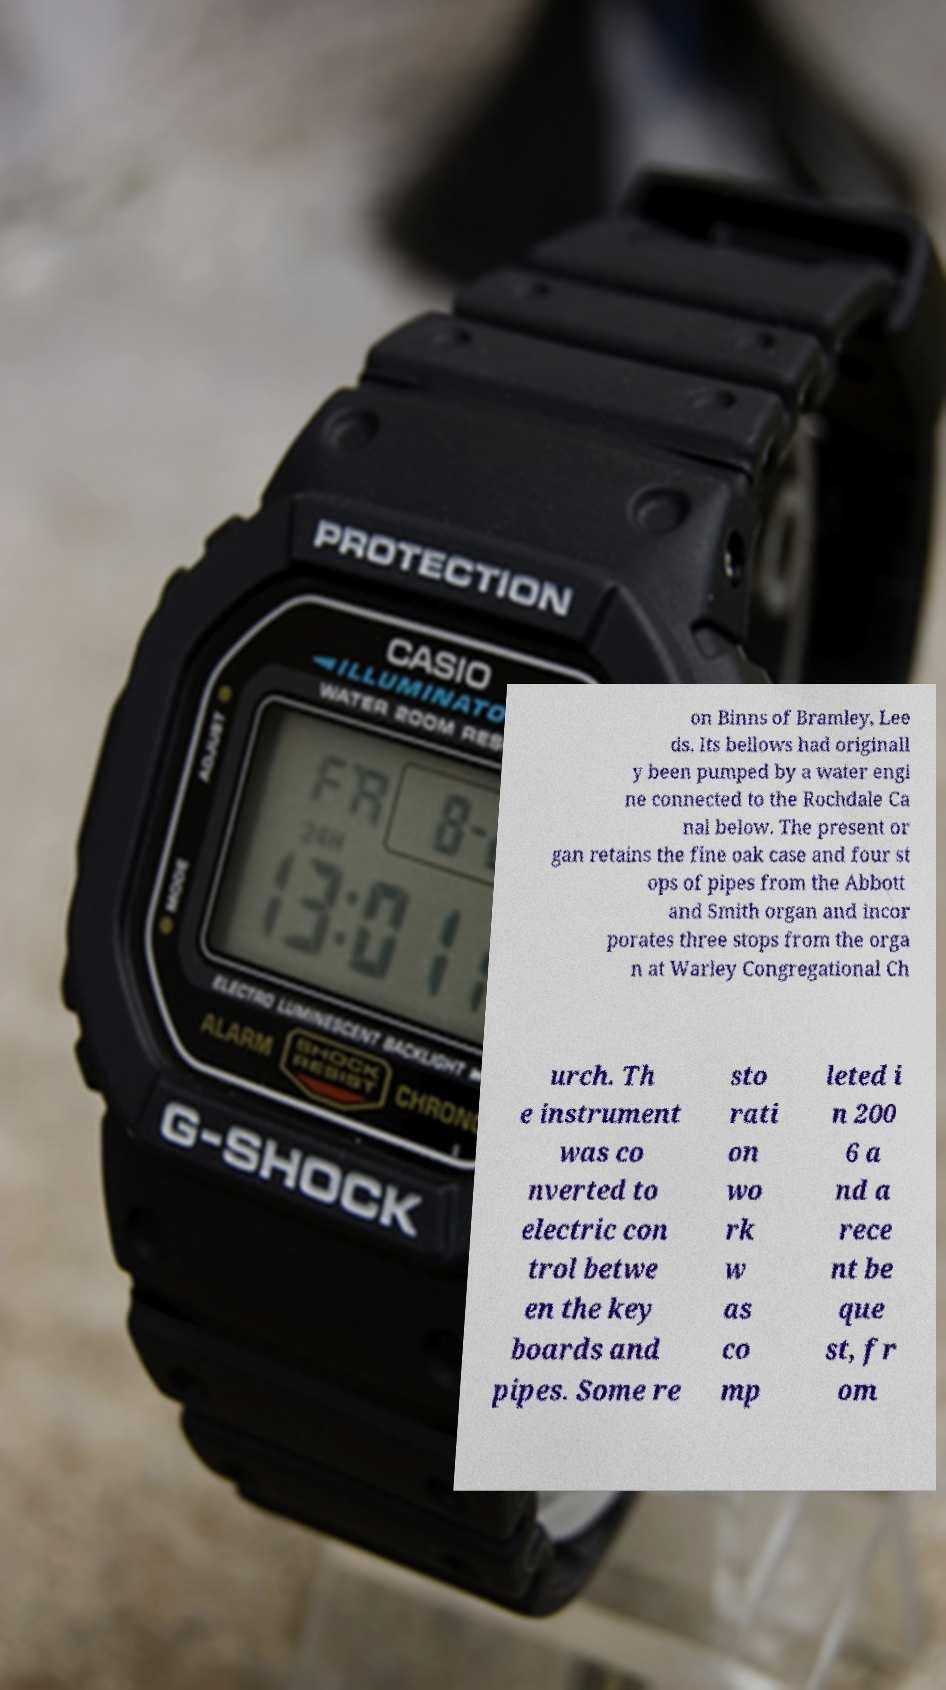Could you assist in decoding the text presented in this image and type it out clearly? on Binns of Bramley, Lee ds. Its bellows had originall y been pumped by a water engi ne connected to the Rochdale Ca nal below. The present or gan retains the fine oak case and four st ops of pipes from the Abbott and Smith organ and incor porates three stops from the orga n at Warley Congregational Ch urch. Th e instrument was co nverted to electric con trol betwe en the key boards and pipes. Some re sto rati on wo rk w as co mp leted i n 200 6 a nd a rece nt be que st, fr om 